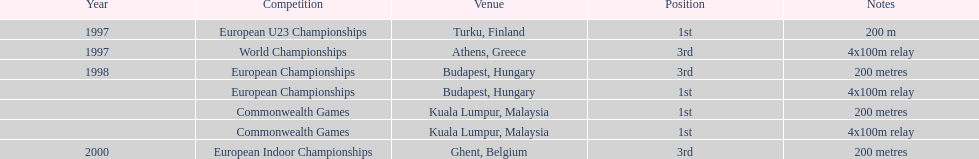How many times was golding in 2nd position? 0. 